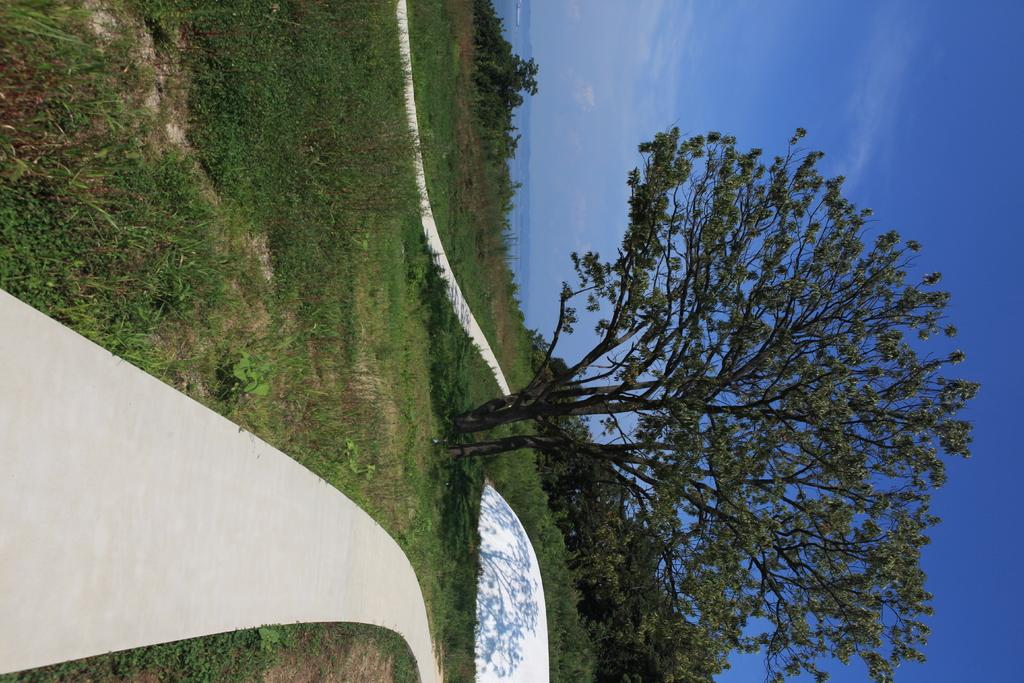What type of vegetation can be seen in the image? There are trees in the image. What is visible in the background of the image? The sky is visible in the background of the image. How would you describe the sky in the image? The sky appears to be clear in the image. What caused the crack in the tree trunk in the image? There is no crack in the tree trunk in the image. What role does the government play in the image? The image does not depict any government involvement or influence. 